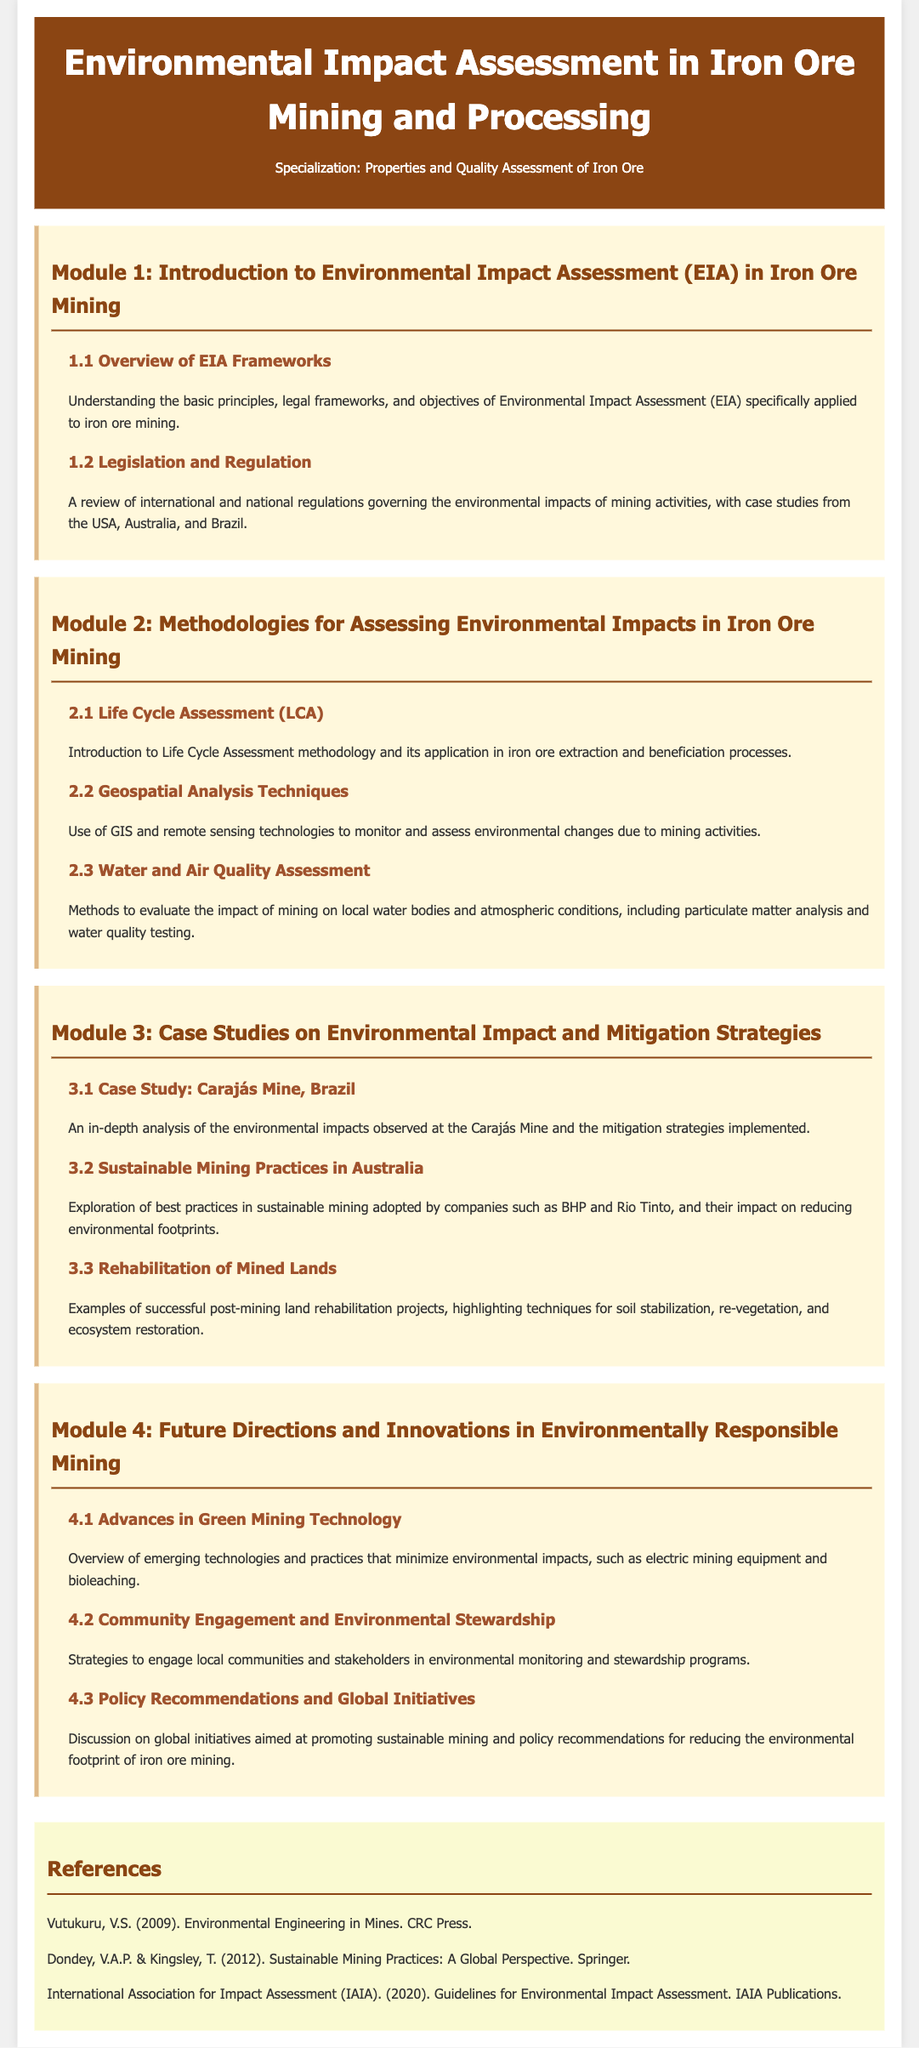What is the title of the syllabus? The title of the syllabus is prominently displayed in the header section of the document.
Answer: Environmental Impact Assessment in Iron Ore Mining and Processing What is the first module about? The first module focuses on the introduction and basic concepts regarding Environmental Impact Assessment in iron ore mining.
Answer: Introduction to Environmental Impact Assessment (EIA) in Iron Ore Mining Which case study is included in Module 3? Module 3 includes specific case studies examining the environmental impacts and mitigation strategies.
Answer: Carajás Mine, Brazil What technology is highlighted in Module 4 that minimizes environmental impacts? Module 4 discusses advancements in technology that contribute to environmentally responsible mining practices.
Answer: Electric mining equipment Who published the guidelines for Environmental Impact Assessment? The guidelines mentioned in the references section are from a specific international association focused on impact assessment.
Answer: International Association for Impact Assessment (IAIA) How many sections or modules are present in the syllabus? The syllabus includes a specific number of thematic sections or modules that help in organizing the content.
Answer: Four 